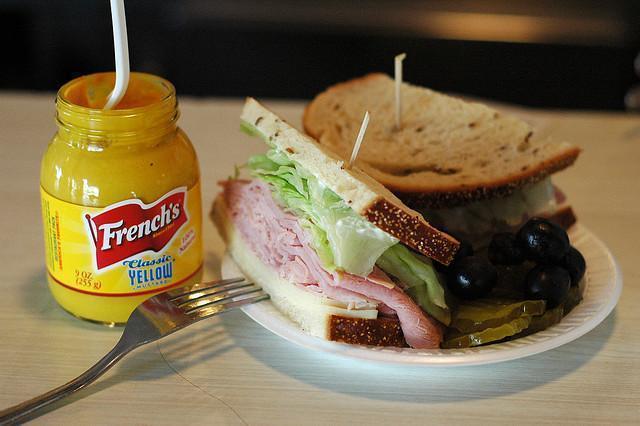Which one of these is a competitor of the company that make's the item in the jar?
Indicate the correct response and explain using: 'Answer: answer
Rationale: rationale.'
Options: Mitsubishi, gulden's, chiquita, apple. Answer: gulden's.
Rationale: Gulden's is another brand of mustard. 